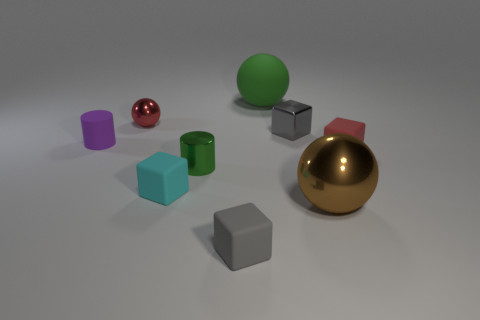Subtract all tiny shiny spheres. How many spheres are left? 2 Subtract all yellow cylinders. How many gray cubes are left? 2 Add 1 small shiny cylinders. How many objects exist? 10 Subtract all cyan cubes. How many cubes are left? 3 Subtract 1 spheres. How many spheres are left? 2 Subtract all blocks. How many objects are left? 5 Subtract all blue cubes. Subtract all brown cylinders. How many cubes are left? 4 Subtract all yellow spheres. Subtract all small metal cylinders. How many objects are left? 8 Add 6 green cylinders. How many green cylinders are left? 7 Add 1 big cyan cylinders. How many big cyan cylinders exist? 1 